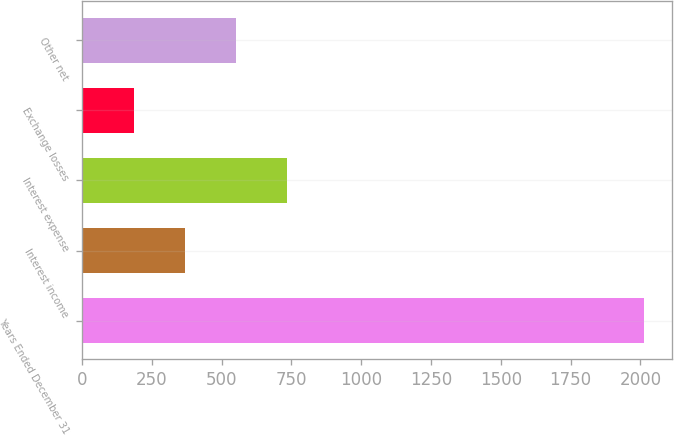<chart> <loc_0><loc_0><loc_500><loc_500><bar_chart><fcel>Years Ended December 31<fcel>Interest income<fcel>Interest expense<fcel>Exchange losses<fcel>Other net<nl><fcel>2012<fcel>367.7<fcel>733.1<fcel>185<fcel>550.4<nl></chart> 